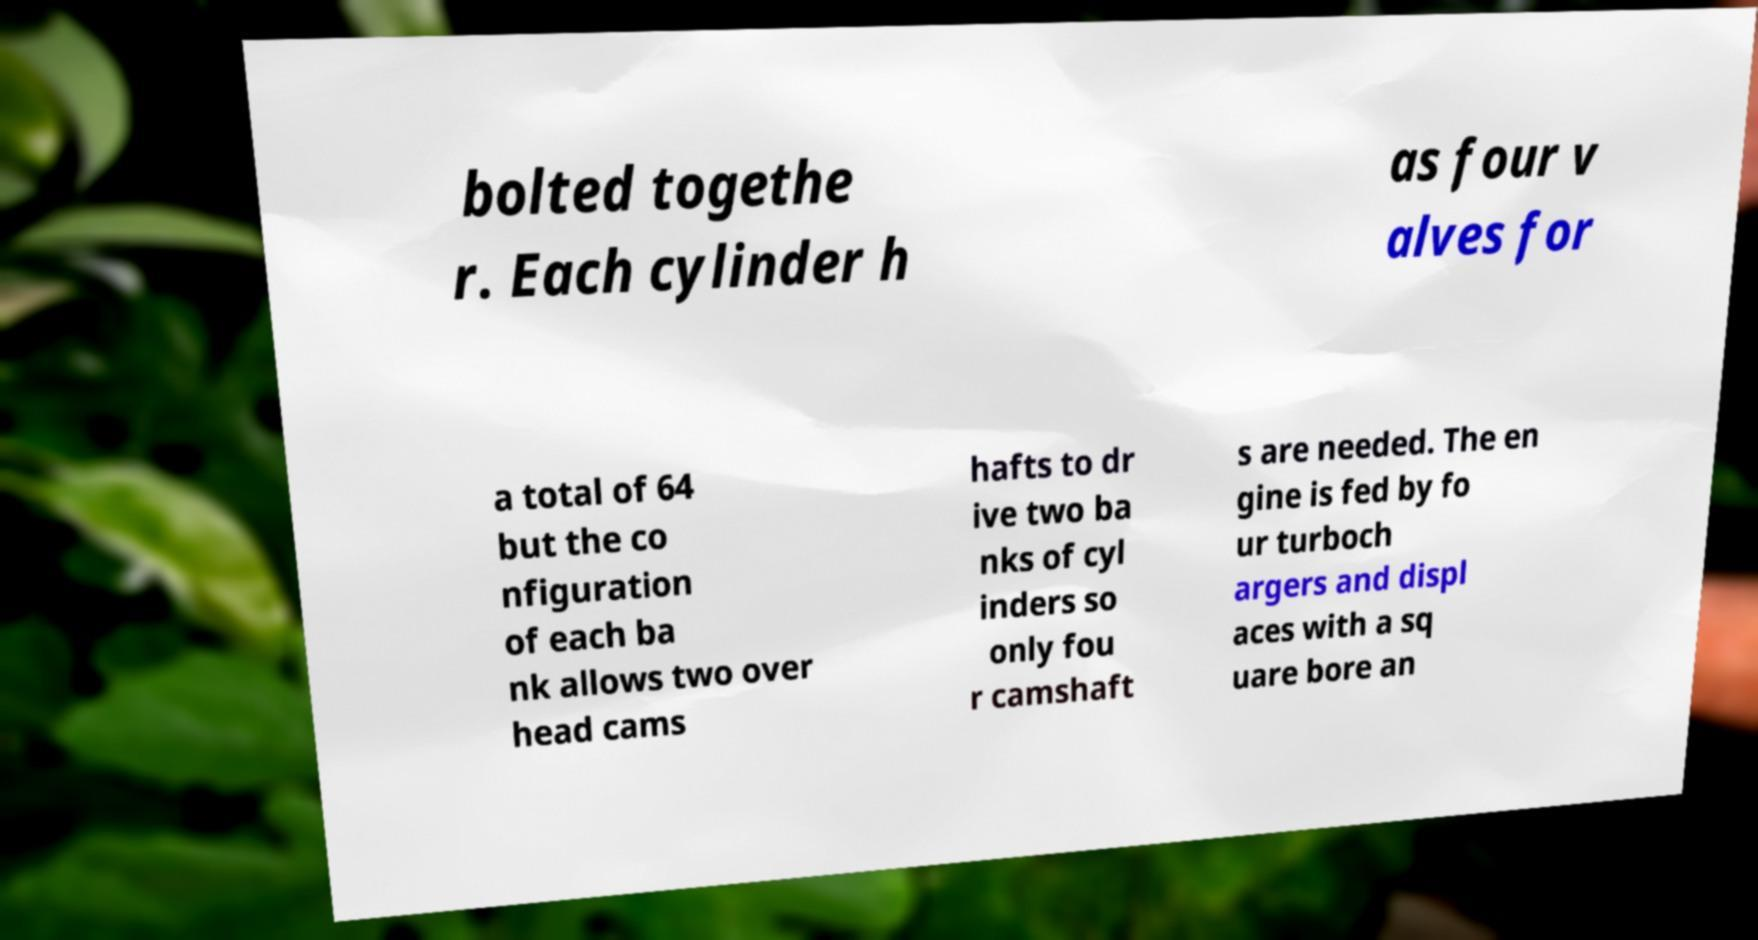For documentation purposes, I need the text within this image transcribed. Could you provide that? bolted togethe r. Each cylinder h as four v alves for a total of 64 but the co nfiguration of each ba nk allows two over head cams hafts to dr ive two ba nks of cyl inders so only fou r camshaft s are needed. The en gine is fed by fo ur turboch argers and displ aces with a sq uare bore an 